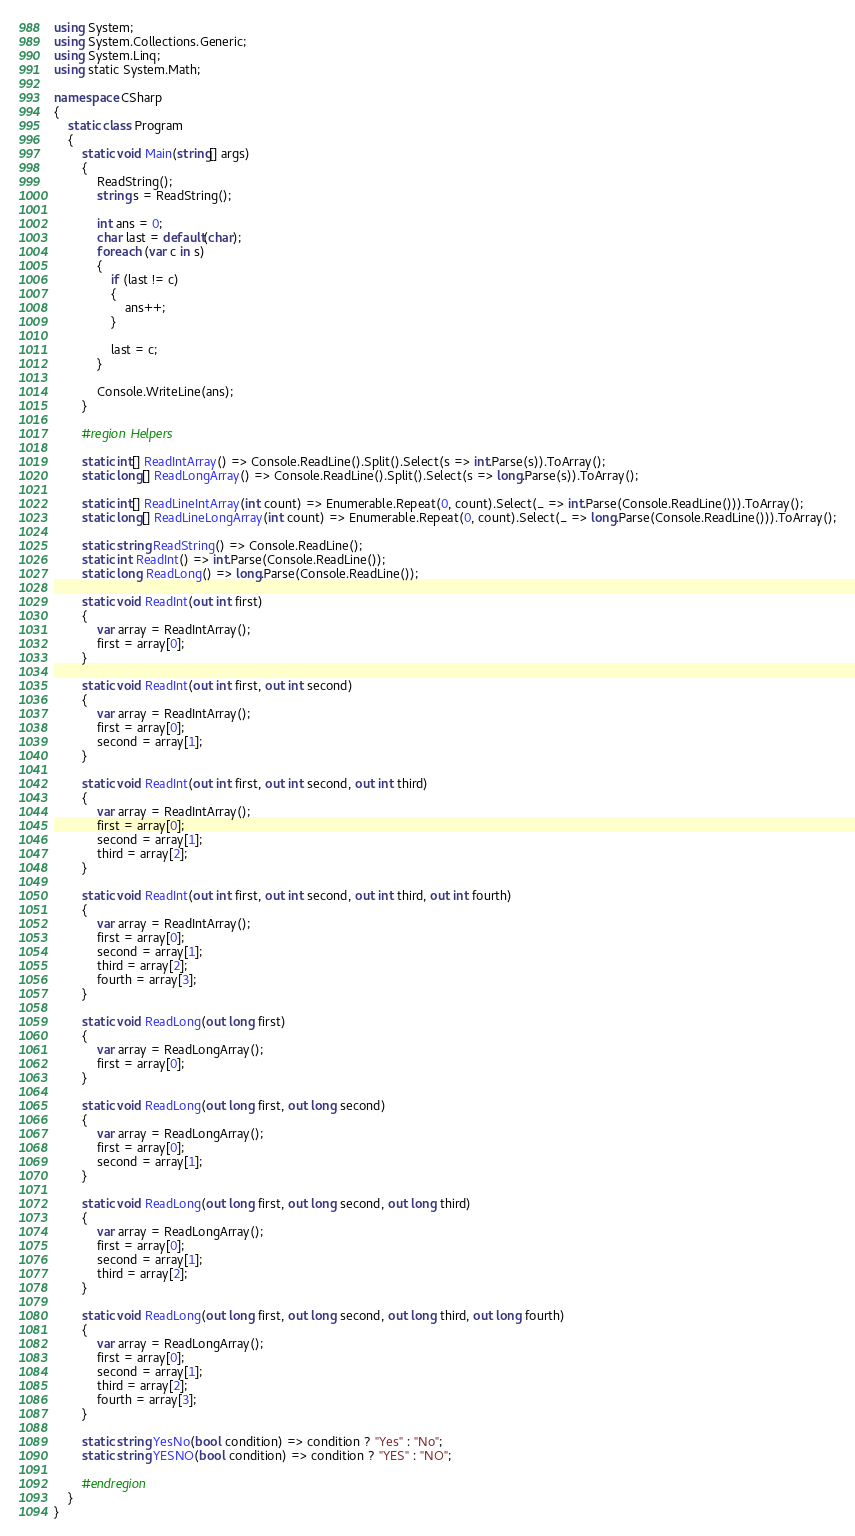Convert code to text. <code><loc_0><loc_0><loc_500><loc_500><_C#_>using System;
using System.Collections.Generic;
using System.Linq;
using static System.Math;

namespace CSharp
{
    static class Program
    {
        static void Main(string[] args)
        {
            ReadString();
            string s = ReadString();

            int ans = 0;
            char last = default(char);
            foreach (var c in s)
            {
                if (last != c)
                {
                    ans++;
                }

                last = c;
            }

            Console.WriteLine(ans);
        }

        #region Helpers

        static int[] ReadIntArray() => Console.ReadLine().Split().Select(s => int.Parse(s)).ToArray();
        static long[] ReadLongArray() => Console.ReadLine().Split().Select(s => long.Parse(s)).ToArray();

        static int[] ReadLineIntArray(int count) => Enumerable.Repeat(0, count).Select(_ => int.Parse(Console.ReadLine())).ToArray();
        static long[] ReadLineLongArray(int count) => Enumerable.Repeat(0, count).Select(_ => long.Parse(Console.ReadLine())).ToArray();

        static string ReadString() => Console.ReadLine();
        static int ReadInt() => int.Parse(Console.ReadLine());
        static long ReadLong() => long.Parse(Console.ReadLine());

        static void ReadInt(out int first)
        {
            var array = ReadIntArray();
            first = array[0];
        }

        static void ReadInt(out int first, out int second)
        {
            var array = ReadIntArray();
            first = array[0];
            second = array[1];
        }

        static void ReadInt(out int first, out int second, out int third)
        {
            var array = ReadIntArray();
            first = array[0];
            second = array[1];
            third = array[2];
        }

        static void ReadInt(out int first, out int second, out int third, out int fourth)
        {
            var array = ReadIntArray();
            first = array[0];
            second = array[1];
            third = array[2];
            fourth = array[3];
        }

        static void ReadLong(out long first)
        {
            var array = ReadLongArray();
            first = array[0];
        }

        static void ReadLong(out long first, out long second)
        {
            var array = ReadLongArray();
            first = array[0];
            second = array[1];
        }

        static void ReadLong(out long first, out long second, out long third)
        {
            var array = ReadLongArray();
            first = array[0];
            second = array[1];
            third = array[2];
        }

        static void ReadLong(out long first, out long second, out long third, out long fourth)
        {
            var array = ReadLongArray();
            first = array[0];
            second = array[1];
            third = array[2];
            fourth = array[3];
        }

        static string YesNo(bool condition) => condition ? "Yes" : "No";
        static string YESNO(bool condition) => condition ? "YES" : "NO";

        #endregion
    }
}</code> 